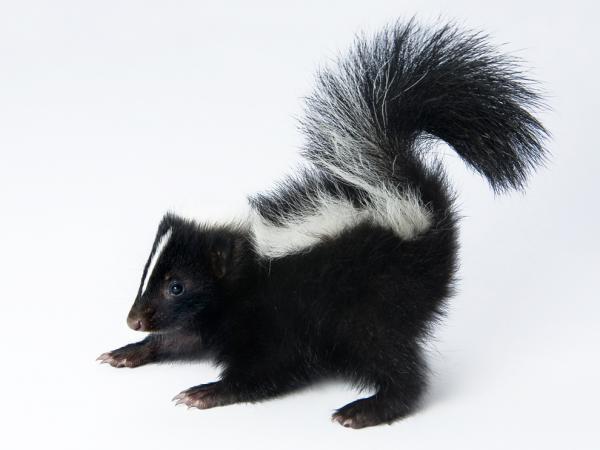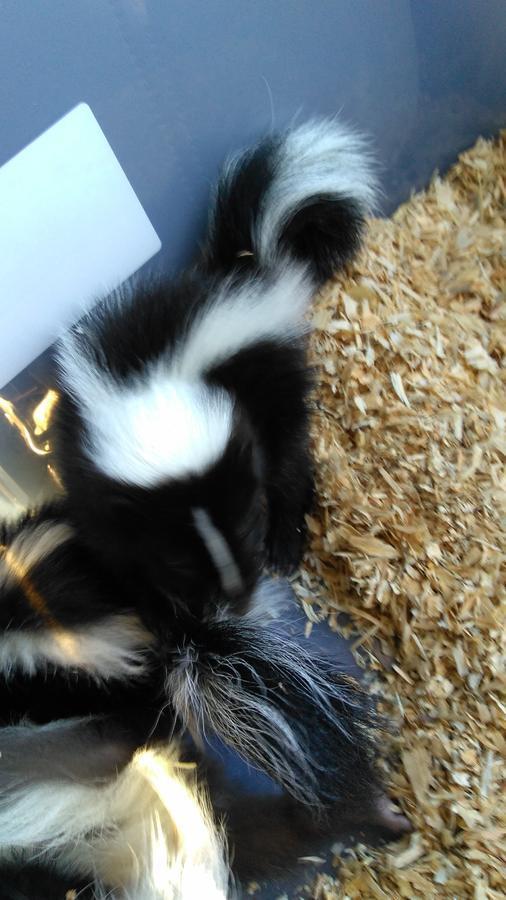The first image is the image on the left, the second image is the image on the right. For the images displayed, is the sentence "Right and left images feature young skunks in containers, but only the container on the left has white bedding in it." factually correct? Answer yes or no. No. The first image is the image on the left, the second image is the image on the right. Analyze the images presented: Is the assertion "All the skunks are in containers." valid? Answer yes or no. No. 